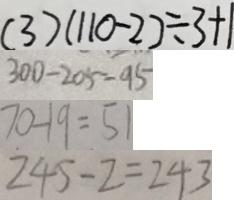<formula> <loc_0><loc_0><loc_500><loc_500>( 3 ) ( 1 1 0 - 2 ) \div 3 + 1 
 3 0 0 - 2 0 5 = 9 5 
 7 0 - 1 9 = 5 1 
 2 4 5 - 2 = 2 4 3</formula> 